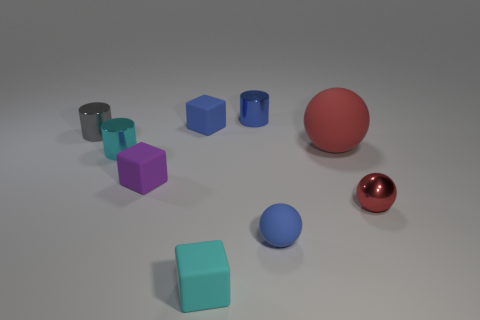What number of small metal objects are left of the blue rubber object that is in front of the tiny gray metallic thing? To the left of the blue rubber object, which is itself positioned directly in front of a tiny gray metallic item on the surface, there appears to be a total of three small metal cylinders. 